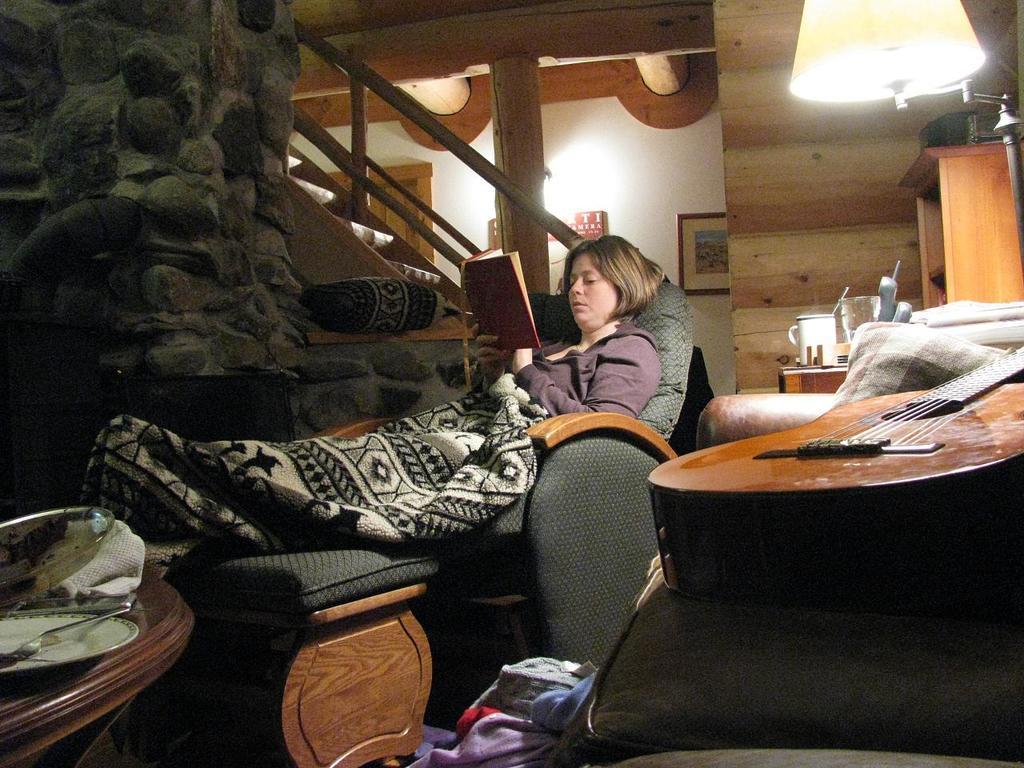Please provide a concise description of this image. In this image the woman is lying on the chair with a book. On the table there is plate. The guitar is on the couch. At the background the frame is attached to the wall. On the right side there is a cupboard. 